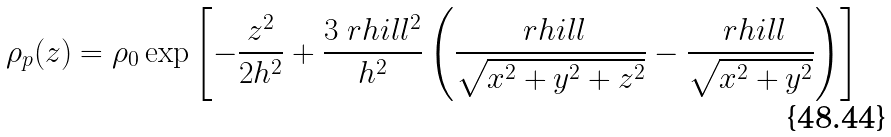Convert formula to latex. <formula><loc_0><loc_0><loc_500><loc_500>\rho _ { p } ( z ) = \rho _ { 0 } \exp \left [ - \frac { z ^ { 2 } } { 2 h ^ { 2 } } + \frac { 3 \ r h i l l ^ { 2 } } { h ^ { 2 } } \left ( \frac { \ r h i l l } { \sqrt { x ^ { 2 } + y ^ { 2 } + z ^ { 2 } } } - \frac { \ r h i l l } { \sqrt { x ^ { 2 } + y ^ { 2 } } } \right ) \right ]</formula> 